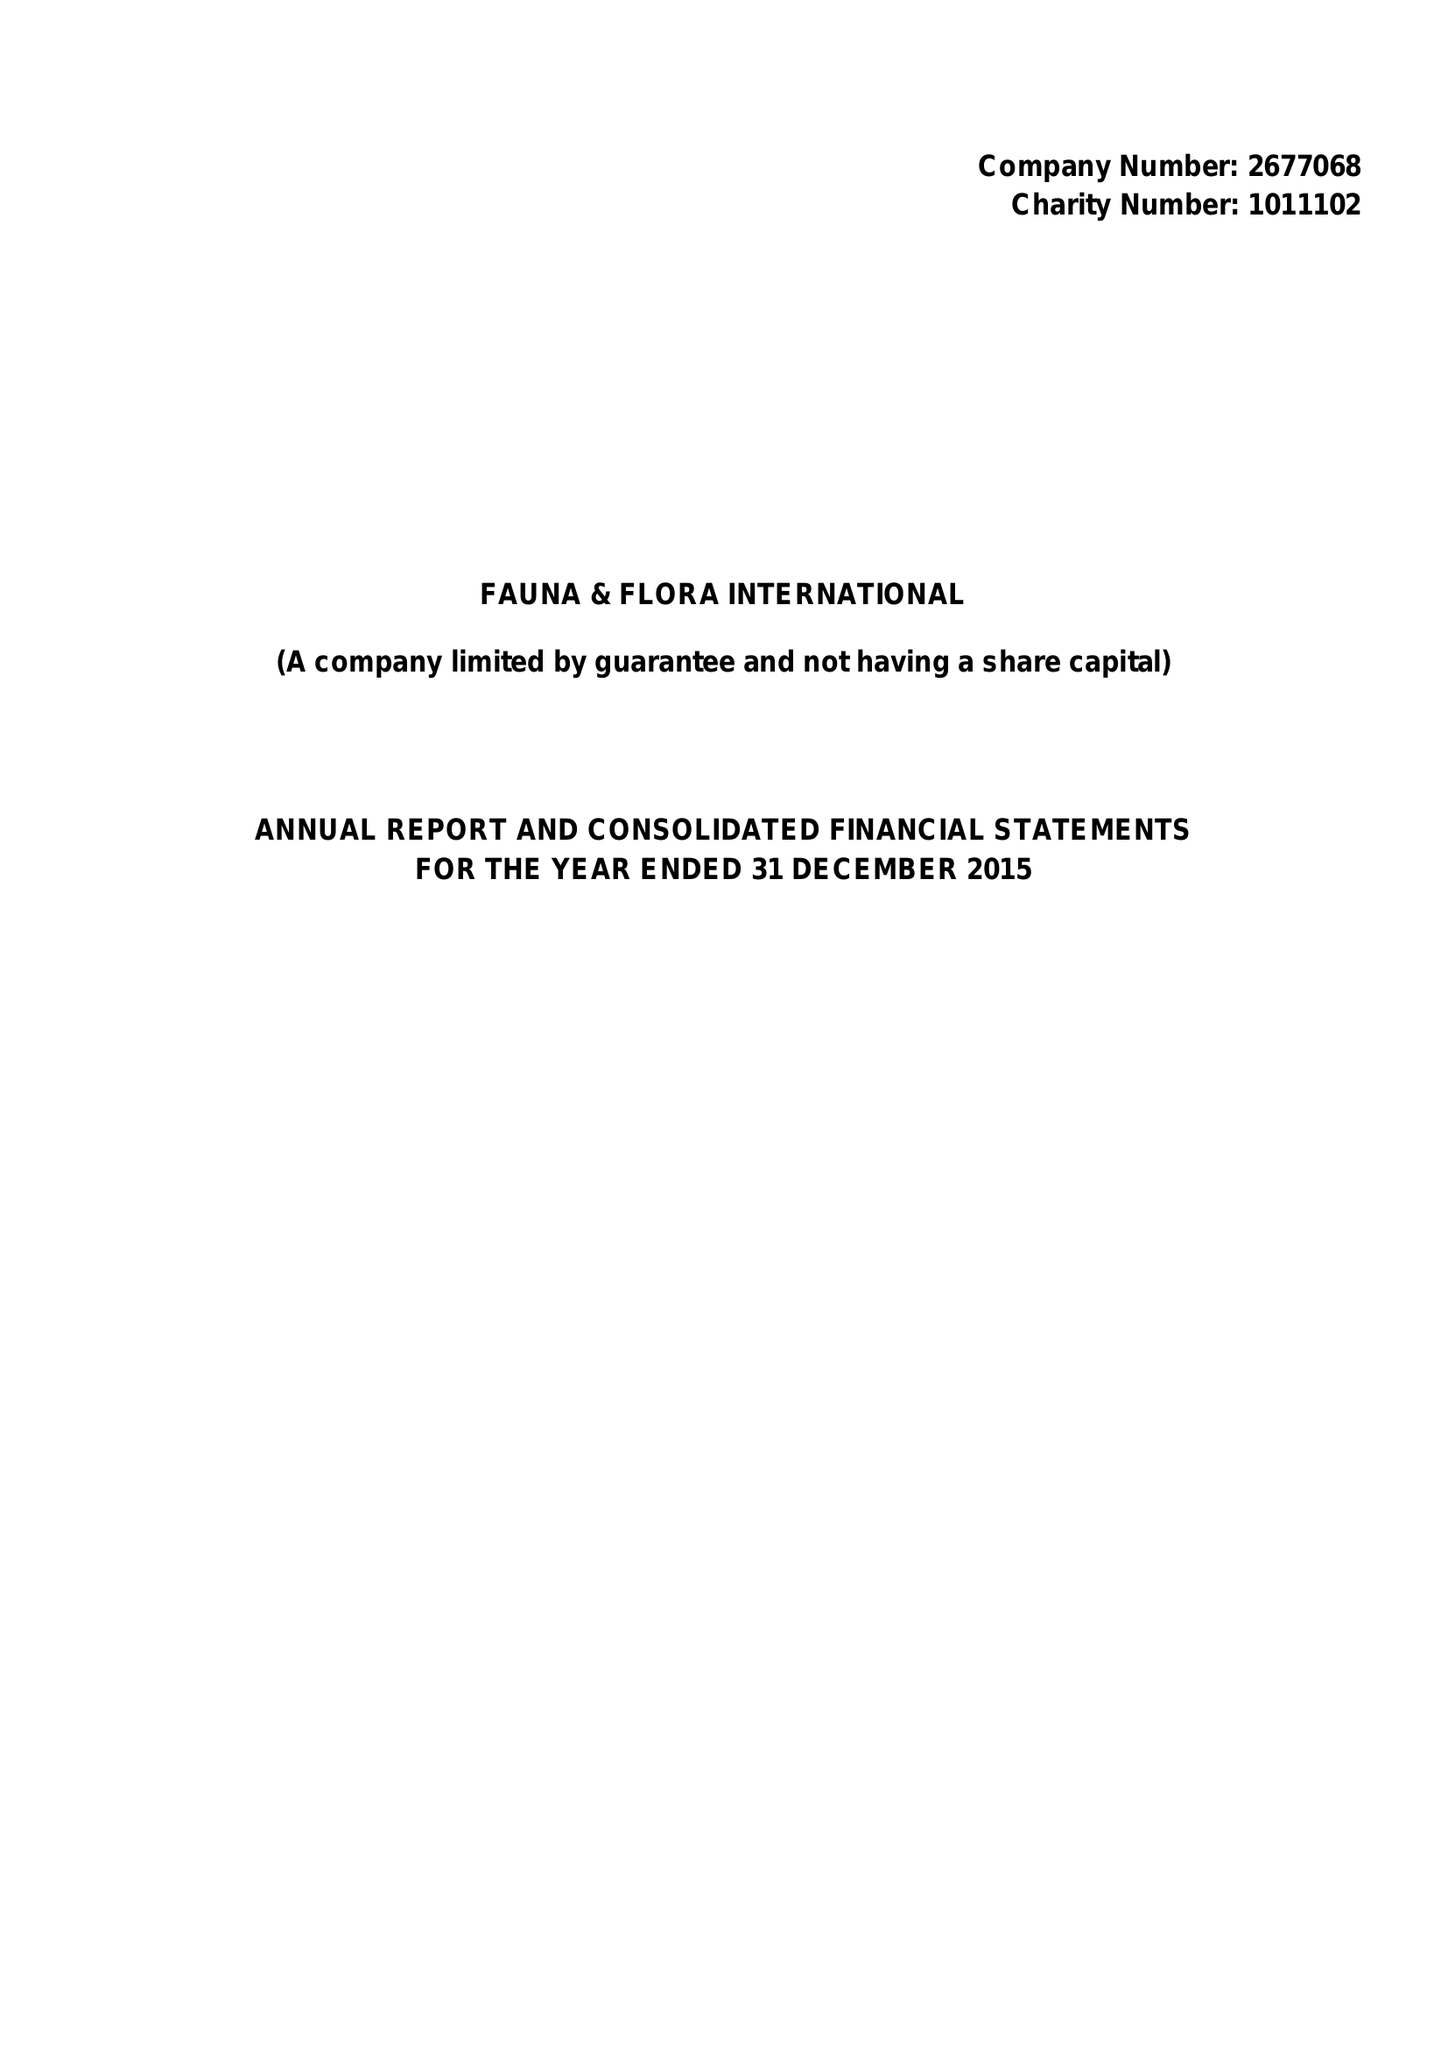What is the value for the address__street_line?
Answer the question using a single word or phrase. PEMBROKE STREET 